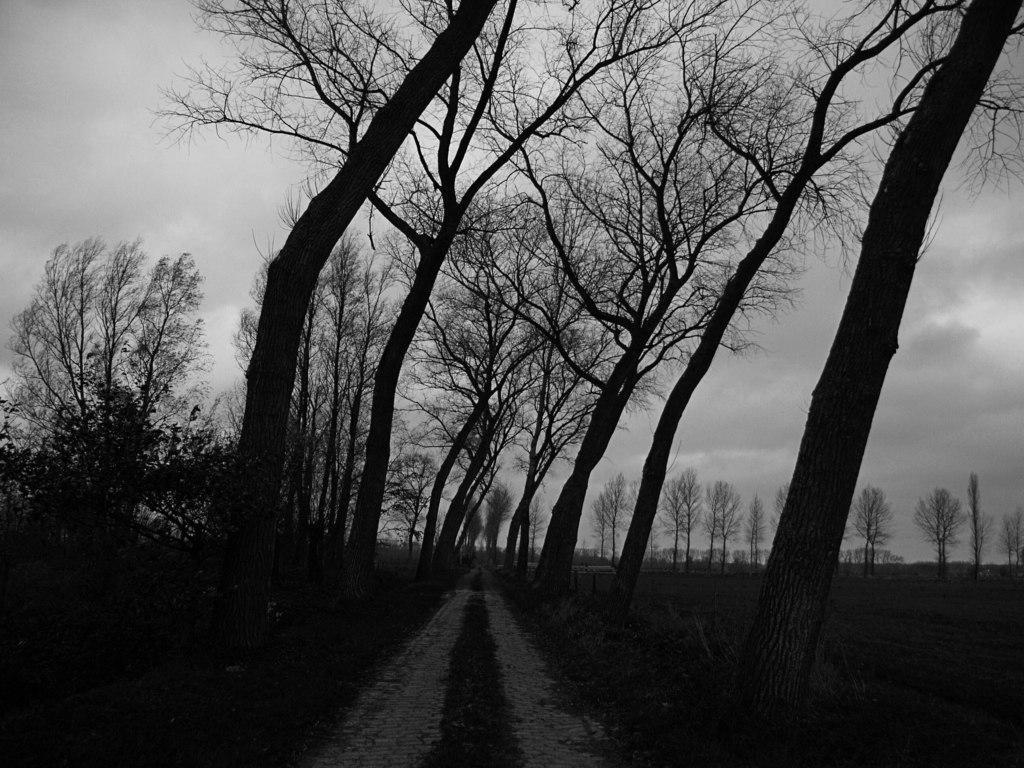Please provide a concise description of this image. In the image we can see black and white image. In the image we can see there are tree branches, path, grass and the cloudy sky. 